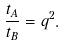<formula> <loc_0><loc_0><loc_500><loc_500>\frac { t _ { A } } { t _ { B } } = q ^ { 2 } .</formula> 